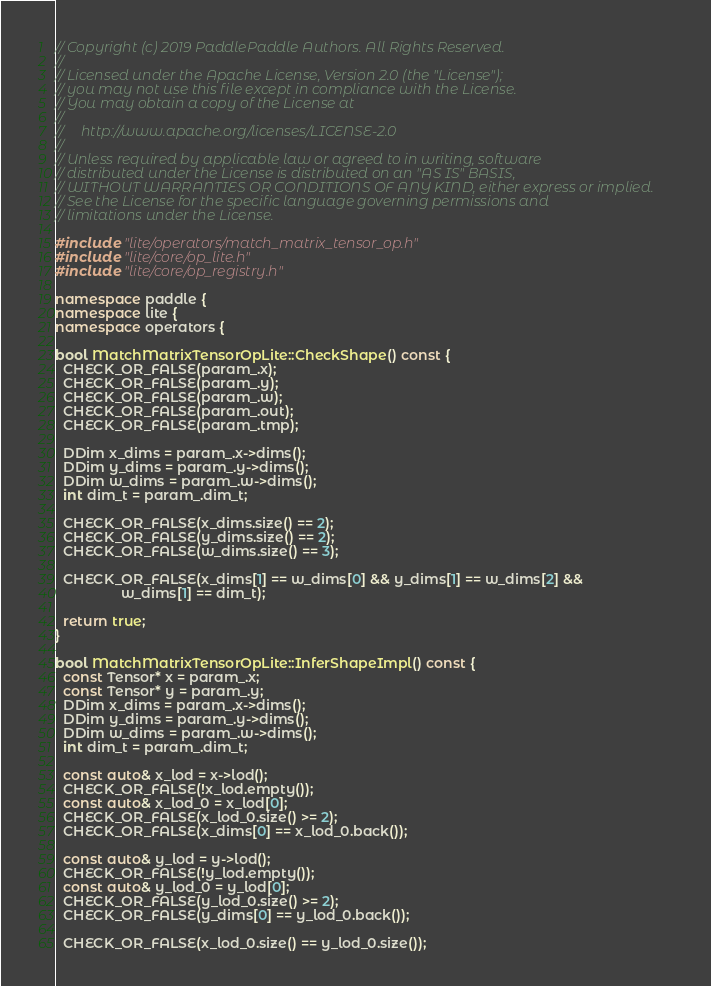Convert code to text. <code><loc_0><loc_0><loc_500><loc_500><_C++_>// Copyright (c) 2019 PaddlePaddle Authors. All Rights Reserved.
//
// Licensed under the Apache License, Version 2.0 (the "License");
// you may not use this file except in compliance with the License.
// You may obtain a copy of the License at
//
//     http://www.apache.org/licenses/LICENSE-2.0
//
// Unless required by applicable law or agreed to in writing, software
// distributed under the License is distributed on an "AS IS" BASIS,
// WITHOUT WARRANTIES OR CONDITIONS OF ANY KIND, either express or implied.
// See the License for the specific language governing permissions and
// limitations under the License.

#include "lite/operators/match_matrix_tensor_op.h"
#include "lite/core/op_lite.h"
#include "lite/core/op_registry.h"

namespace paddle {
namespace lite {
namespace operators {

bool MatchMatrixTensorOpLite::CheckShape() const {
  CHECK_OR_FALSE(param_.x);
  CHECK_OR_FALSE(param_.y);
  CHECK_OR_FALSE(param_.w);
  CHECK_OR_FALSE(param_.out);
  CHECK_OR_FALSE(param_.tmp);

  DDim x_dims = param_.x->dims();
  DDim y_dims = param_.y->dims();
  DDim w_dims = param_.w->dims();
  int dim_t = param_.dim_t;

  CHECK_OR_FALSE(x_dims.size() == 2);
  CHECK_OR_FALSE(y_dims.size() == 2);
  CHECK_OR_FALSE(w_dims.size() == 3);

  CHECK_OR_FALSE(x_dims[1] == w_dims[0] && y_dims[1] == w_dims[2] &&
                 w_dims[1] == dim_t);

  return true;
}

bool MatchMatrixTensorOpLite::InferShapeImpl() const {
  const Tensor* x = param_.x;
  const Tensor* y = param_.y;
  DDim x_dims = param_.x->dims();
  DDim y_dims = param_.y->dims();
  DDim w_dims = param_.w->dims();
  int dim_t = param_.dim_t;

  const auto& x_lod = x->lod();
  CHECK_OR_FALSE(!x_lod.empty());
  const auto& x_lod_0 = x_lod[0];
  CHECK_OR_FALSE(x_lod_0.size() >= 2);
  CHECK_OR_FALSE(x_dims[0] == x_lod_0.back());

  const auto& y_lod = y->lod();
  CHECK_OR_FALSE(!y_lod.empty());
  const auto& y_lod_0 = y_lod[0];
  CHECK_OR_FALSE(y_lod_0.size() >= 2);
  CHECK_OR_FALSE(y_dims[0] == y_lod_0.back());

  CHECK_OR_FALSE(x_lod_0.size() == y_lod_0.size());
</code> 